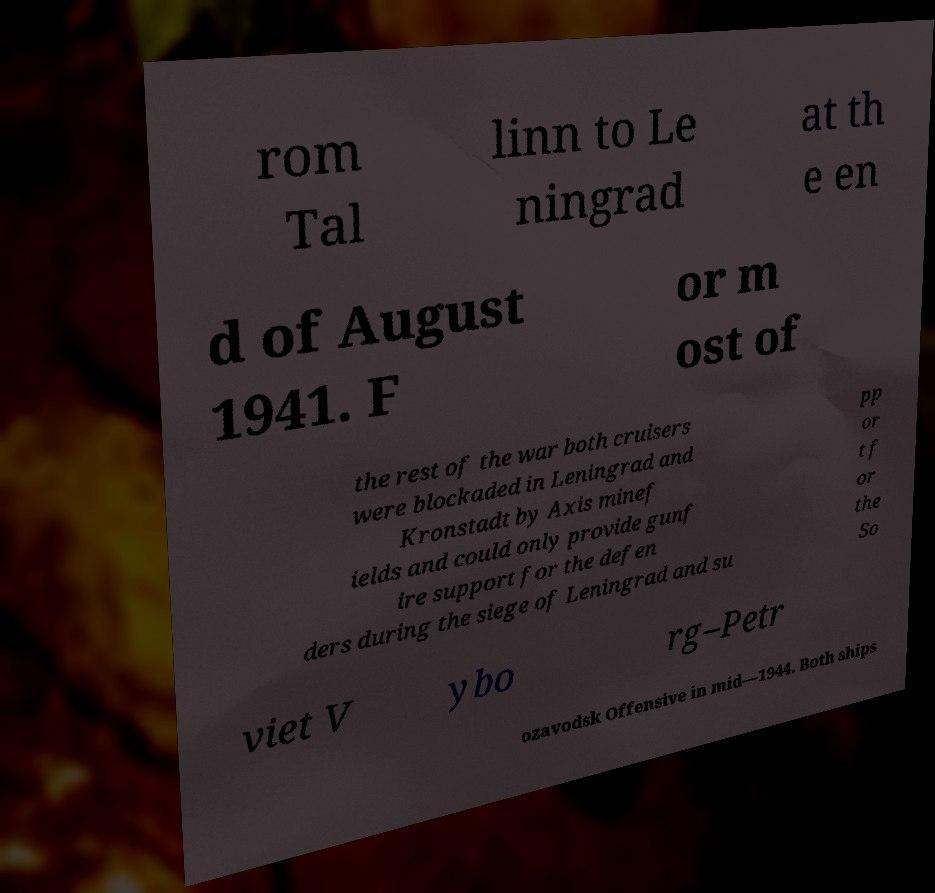There's text embedded in this image that I need extracted. Can you transcribe it verbatim? rom Tal linn to Le ningrad at th e en d of August 1941. F or m ost of the rest of the war both cruisers were blockaded in Leningrad and Kronstadt by Axis minef ields and could only provide gunf ire support for the defen ders during the siege of Leningrad and su pp or t f or the So viet V ybo rg–Petr ozavodsk Offensive in mid—1944. Both ships 